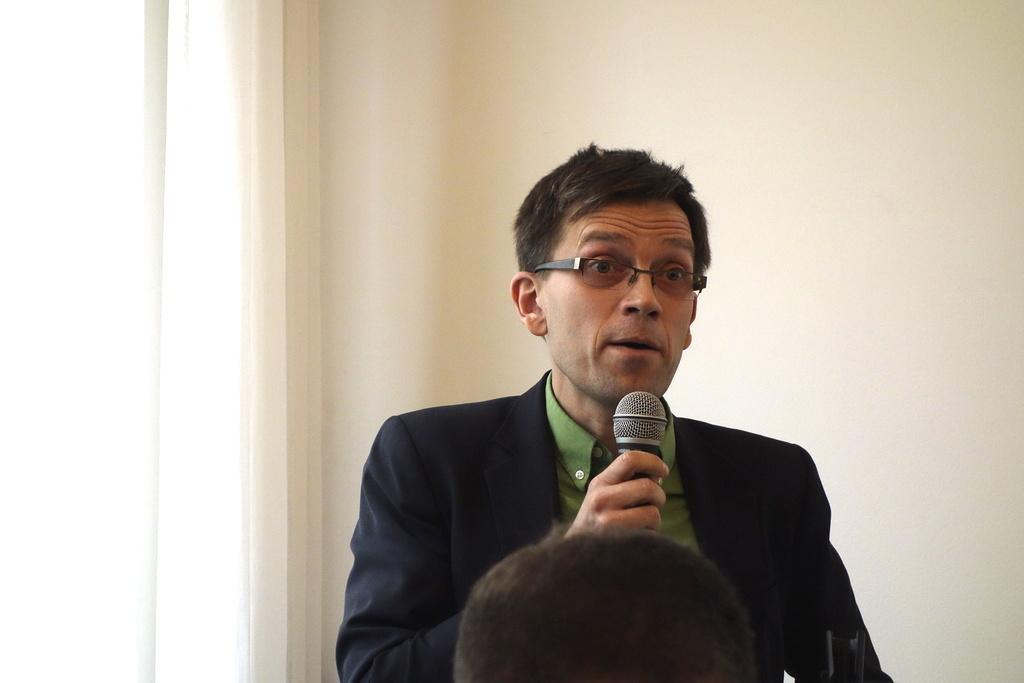Who or what is the main subject in the image? There is a person in the image. What is the person wearing? The person is wearing a black suit. What object is the person holding in their hand? The person is holding a microphone in their hand. Can you see any rivers or bodies of water in the image? There are no rivers or bodies of water visible in the image. How many rings is the person wearing on their fingers in the image? The person is not wearing any rings in the image. 